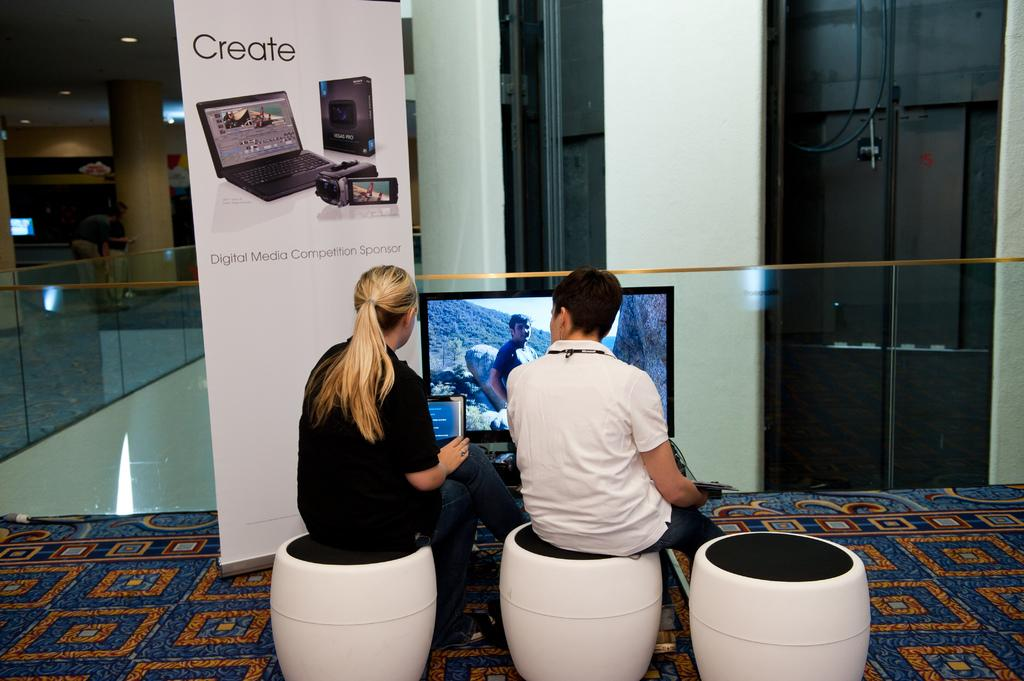<image>
Write a terse but informative summary of the picture. Two people sitting in front of a screen next to a sign that says CREATE. 